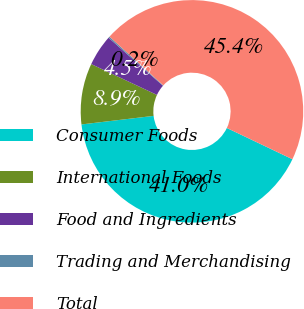<chart> <loc_0><loc_0><loc_500><loc_500><pie_chart><fcel>Consumer Foods<fcel>International Foods<fcel>Food and Ingredients<fcel>Trading and Merchandising<fcel>Total<nl><fcel>41.04%<fcel>8.86%<fcel>4.53%<fcel>0.2%<fcel>45.37%<nl></chart> 